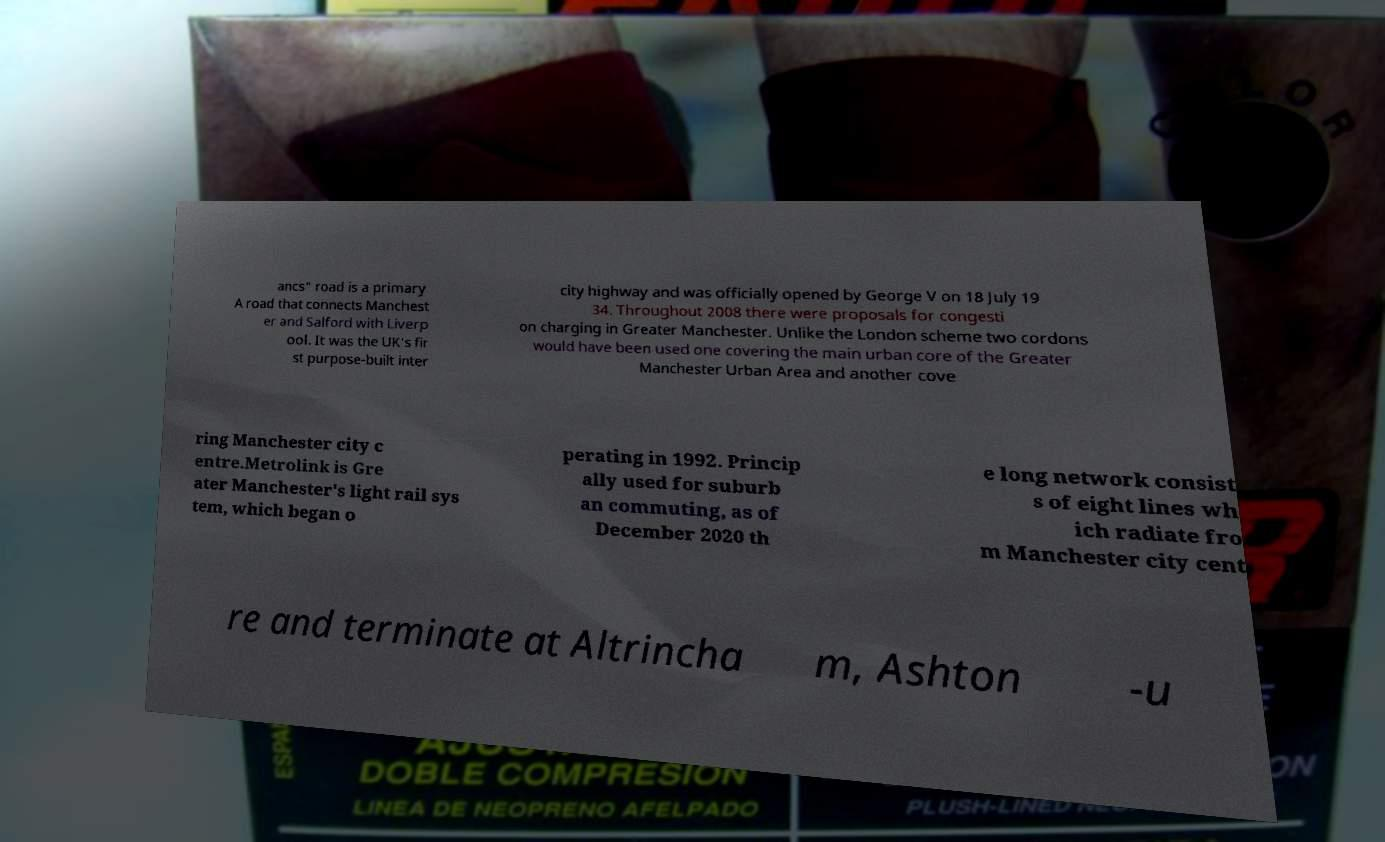Could you assist in decoding the text presented in this image and type it out clearly? ancs" road is a primary A road that connects Manchest er and Salford with Liverp ool. It was the UK's fir st purpose-built inter city highway and was officially opened by George V on 18 July 19 34. Throughout 2008 there were proposals for congesti on charging in Greater Manchester. Unlike the London scheme two cordons would have been used one covering the main urban core of the Greater Manchester Urban Area and another cove ring Manchester city c entre.Metrolink is Gre ater Manchester's light rail sys tem, which began o perating in 1992. Princip ally used for suburb an commuting, as of December 2020 th e long network consist s of eight lines wh ich radiate fro m Manchester city cent re and terminate at Altrincha m, Ashton -u 